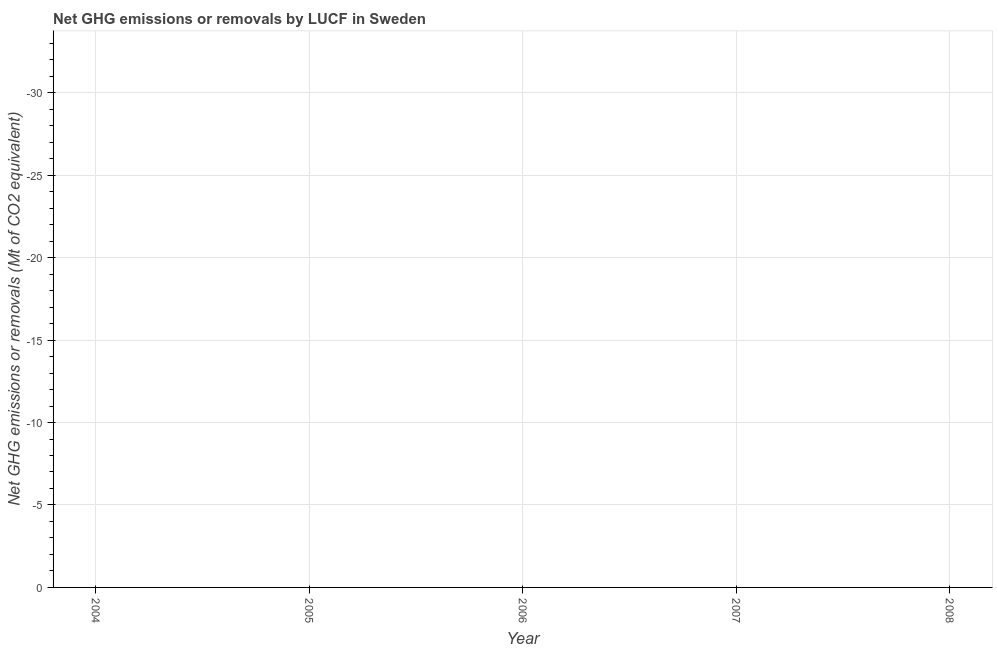What is the ghg net emissions or removals in 2005?
Offer a very short reply. 0. What is the average ghg net emissions or removals per year?
Keep it short and to the point. 0. Does the ghg net emissions or removals monotonically increase over the years?
Your response must be concise. Yes. How many lines are there?
Offer a terse response. 0. How many years are there in the graph?
Offer a terse response. 5. What is the difference between two consecutive major ticks on the Y-axis?
Your answer should be very brief. 5. Are the values on the major ticks of Y-axis written in scientific E-notation?
Offer a very short reply. No. What is the title of the graph?
Offer a very short reply. Net GHG emissions or removals by LUCF in Sweden. What is the label or title of the Y-axis?
Keep it short and to the point. Net GHG emissions or removals (Mt of CO2 equivalent). What is the Net GHG emissions or removals (Mt of CO2 equivalent) in 2006?
Make the answer very short. 0. 